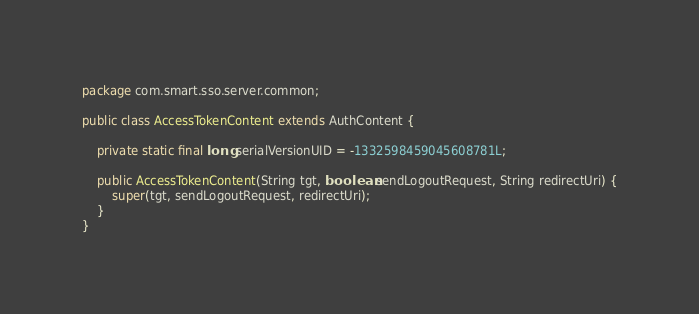<code> <loc_0><loc_0><loc_500><loc_500><_Java_>package com.smart.sso.server.common;

public class AccessTokenContent extends AuthContent {

	private static final long serialVersionUID = -1332598459045608781L;

	public AccessTokenContent(String tgt, boolean sendLogoutRequest, String redirectUri) {
		super(tgt, sendLogoutRequest, redirectUri);
	}
}</code> 